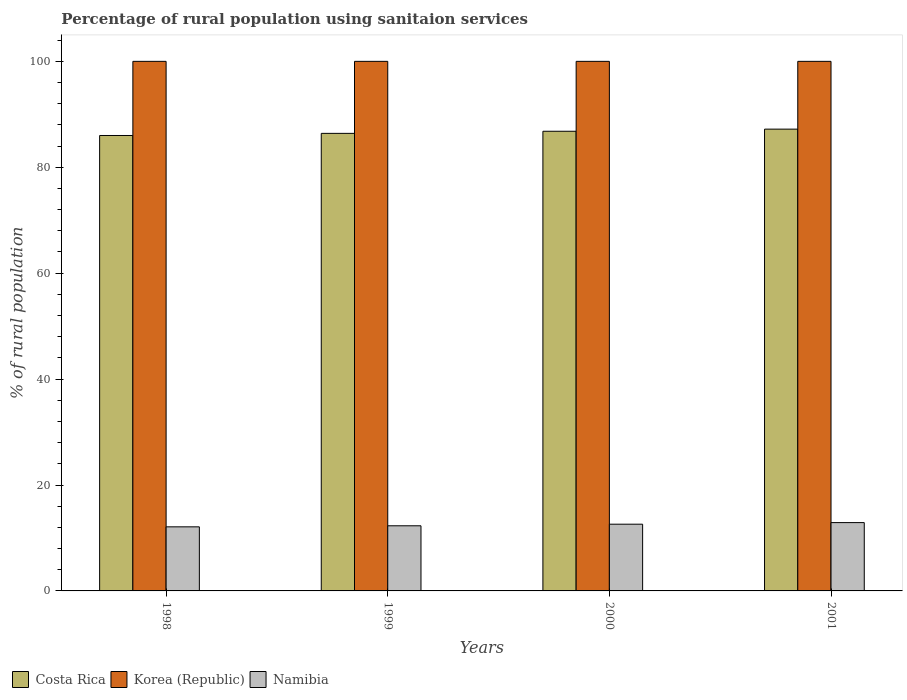How many different coloured bars are there?
Your answer should be compact. 3. How many groups of bars are there?
Your answer should be compact. 4. Are the number of bars on each tick of the X-axis equal?
Your response must be concise. Yes. How many bars are there on the 4th tick from the right?
Ensure brevity in your answer.  3. What is the label of the 3rd group of bars from the left?
Your answer should be compact. 2000. In how many cases, is the number of bars for a given year not equal to the number of legend labels?
Keep it short and to the point. 0. Across all years, what is the maximum percentage of rural population using sanitaion services in Costa Rica?
Your answer should be very brief. 87.2. In which year was the percentage of rural population using sanitaion services in Namibia minimum?
Keep it short and to the point. 1998. What is the total percentage of rural population using sanitaion services in Namibia in the graph?
Your answer should be very brief. 49.9. What is the difference between the percentage of rural population using sanitaion services in Costa Rica in 2000 and that in 2001?
Give a very brief answer. -0.4. What is the difference between the percentage of rural population using sanitaion services in Korea (Republic) in 2000 and the percentage of rural population using sanitaion services in Costa Rica in 1999?
Make the answer very short. 13.6. In the year 1998, what is the difference between the percentage of rural population using sanitaion services in Korea (Republic) and percentage of rural population using sanitaion services in Costa Rica?
Your answer should be very brief. 14. Is the percentage of rural population using sanitaion services in Korea (Republic) in 1998 less than that in 2001?
Your answer should be compact. No. Is the difference between the percentage of rural population using sanitaion services in Korea (Republic) in 1998 and 1999 greater than the difference between the percentage of rural population using sanitaion services in Costa Rica in 1998 and 1999?
Offer a very short reply. Yes. What is the difference between the highest and the second highest percentage of rural population using sanitaion services in Costa Rica?
Give a very brief answer. 0.4. What is the difference between the highest and the lowest percentage of rural population using sanitaion services in Namibia?
Your answer should be compact. 0.8. In how many years, is the percentage of rural population using sanitaion services in Costa Rica greater than the average percentage of rural population using sanitaion services in Costa Rica taken over all years?
Offer a terse response. 2. What does the 3rd bar from the left in 1999 represents?
Keep it short and to the point. Namibia. What does the 1st bar from the right in 2000 represents?
Your response must be concise. Namibia. Are all the bars in the graph horizontal?
Offer a terse response. No. What is the difference between two consecutive major ticks on the Y-axis?
Keep it short and to the point. 20. Are the values on the major ticks of Y-axis written in scientific E-notation?
Give a very brief answer. No. How many legend labels are there?
Ensure brevity in your answer.  3. How are the legend labels stacked?
Provide a short and direct response. Horizontal. What is the title of the graph?
Offer a terse response. Percentage of rural population using sanitaion services. What is the label or title of the X-axis?
Keep it short and to the point. Years. What is the label or title of the Y-axis?
Give a very brief answer. % of rural population. What is the % of rural population in Costa Rica in 1998?
Ensure brevity in your answer.  86. What is the % of rural population in Costa Rica in 1999?
Provide a succinct answer. 86.4. What is the % of rural population of Costa Rica in 2000?
Offer a terse response. 86.8. What is the % of rural population of Korea (Republic) in 2000?
Your answer should be compact. 100. What is the % of rural population in Namibia in 2000?
Make the answer very short. 12.6. What is the % of rural population in Costa Rica in 2001?
Provide a succinct answer. 87.2. Across all years, what is the maximum % of rural population of Costa Rica?
Offer a terse response. 87.2. Across all years, what is the maximum % of rural population in Korea (Republic)?
Your answer should be very brief. 100. Across all years, what is the minimum % of rural population in Costa Rica?
Offer a terse response. 86. What is the total % of rural population in Costa Rica in the graph?
Your answer should be very brief. 346.4. What is the total % of rural population of Namibia in the graph?
Your response must be concise. 49.9. What is the difference between the % of rural population in Costa Rica in 1998 and that in 1999?
Your response must be concise. -0.4. What is the difference between the % of rural population of Korea (Republic) in 1998 and that in 2000?
Your response must be concise. 0. What is the difference between the % of rural population of Costa Rica in 1998 and that in 2001?
Give a very brief answer. -1.2. What is the difference between the % of rural population of Korea (Republic) in 1998 and that in 2001?
Keep it short and to the point. 0. What is the difference between the % of rural population in Korea (Republic) in 1999 and that in 2000?
Keep it short and to the point. 0. What is the difference between the % of rural population in Namibia in 1999 and that in 2000?
Offer a terse response. -0.3. What is the difference between the % of rural population in Costa Rica in 2000 and that in 2001?
Provide a succinct answer. -0.4. What is the difference between the % of rural population of Costa Rica in 1998 and the % of rural population of Namibia in 1999?
Keep it short and to the point. 73.7. What is the difference between the % of rural population in Korea (Republic) in 1998 and the % of rural population in Namibia in 1999?
Offer a very short reply. 87.7. What is the difference between the % of rural population of Costa Rica in 1998 and the % of rural population of Korea (Republic) in 2000?
Your answer should be compact. -14. What is the difference between the % of rural population in Costa Rica in 1998 and the % of rural population in Namibia in 2000?
Your answer should be compact. 73.4. What is the difference between the % of rural population in Korea (Republic) in 1998 and the % of rural population in Namibia in 2000?
Your answer should be compact. 87.4. What is the difference between the % of rural population in Costa Rica in 1998 and the % of rural population in Namibia in 2001?
Keep it short and to the point. 73.1. What is the difference between the % of rural population in Korea (Republic) in 1998 and the % of rural population in Namibia in 2001?
Your answer should be compact. 87.1. What is the difference between the % of rural population of Costa Rica in 1999 and the % of rural population of Korea (Republic) in 2000?
Offer a very short reply. -13.6. What is the difference between the % of rural population in Costa Rica in 1999 and the % of rural population in Namibia in 2000?
Offer a very short reply. 73.8. What is the difference between the % of rural population in Korea (Republic) in 1999 and the % of rural population in Namibia in 2000?
Make the answer very short. 87.4. What is the difference between the % of rural population in Costa Rica in 1999 and the % of rural population in Namibia in 2001?
Provide a short and direct response. 73.5. What is the difference between the % of rural population in Korea (Republic) in 1999 and the % of rural population in Namibia in 2001?
Provide a succinct answer. 87.1. What is the difference between the % of rural population in Costa Rica in 2000 and the % of rural population in Korea (Republic) in 2001?
Your response must be concise. -13.2. What is the difference between the % of rural population of Costa Rica in 2000 and the % of rural population of Namibia in 2001?
Offer a very short reply. 73.9. What is the difference between the % of rural population in Korea (Republic) in 2000 and the % of rural population in Namibia in 2001?
Give a very brief answer. 87.1. What is the average % of rural population of Costa Rica per year?
Your answer should be compact. 86.6. What is the average % of rural population in Namibia per year?
Your answer should be very brief. 12.47. In the year 1998, what is the difference between the % of rural population in Costa Rica and % of rural population in Korea (Republic)?
Keep it short and to the point. -14. In the year 1998, what is the difference between the % of rural population in Costa Rica and % of rural population in Namibia?
Give a very brief answer. 73.9. In the year 1998, what is the difference between the % of rural population in Korea (Republic) and % of rural population in Namibia?
Provide a succinct answer. 87.9. In the year 1999, what is the difference between the % of rural population of Costa Rica and % of rural population of Korea (Republic)?
Keep it short and to the point. -13.6. In the year 1999, what is the difference between the % of rural population of Costa Rica and % of rural population of Namibia?
Your answer should be very brief. 74.1. In the year 1999, what is the difference between the % of rural population in Korea (Republic) and % of rural population in Namibia?
Offer a terse response. 87.7. In the year 2000, what is the difference between the % of rural population in Costa Rica and % of rural population in Korea (Republic)?
Give a very brief answer. -13.2. In the year 2000, what is the difference between the % of rural population of Costa Rica and % of rural population of Namibia?
Give a very brief answer. 74.2. In the year 2000, what is the difference between the % of rural population in Korea (Republic) and % of rural population in Namibia?
Offer a terse response. 87.4. In the year 2001, what is the difference between the % of rural population of Costa Rica and % of rural population of Korea (Republic)?
Your answer should be compact. -12.8. In the year 2001, what is the difference between the % of rural population in Costa Rica and % of rural population in Namibia?
Your response must be concise. 74.3. In the year 2001, what is the difference between the % of rural population of Korea (Republic) and % of rural population of Namibia?
Make the answer very short. 87.1. What is the ratio of the % of rural population in Costa Rica in 1998 to that in 1999?
Provide a short and direct response. 1. What is the ratio of the % of rural population in Namibia in 1998 to that in 1999?
Provide a succinct answer. 0.98. What is the ratio of the % of rural population of Korea (Republic) in 1998 to that in 2000?
Offer a terse response. 1. What is the ratio of the % of rural population of Namibia in 1998 to that in 2000?
Your response must be concise. 0.96. What is the ratio of the % of rural population of Costa Rica in 1998 to that in 2001?
Keep it short and to the point. 0.99. What is the ratio of the % of rural population in Namibia in 1998 to that in 2001?
Give a very brief answer. 0.94. What is the ratio of the % of rural population in Namibia in 1999 to that in 2000?
Your answer should be very brief. 0.98. What is the ratio of the % of rural population of Namibia in 1999 to that in 2001?
Give a very brief answer. 0.95. What is the ratio of the % of rural population of Korea (Republic) in 2000 to that in 2001?
Your answer should be compact. 1. What is the ratio of the % of rural population in Namibia in 2000 to that in 2001?
Your response must be concise. 0.98. What is the difference between the highest and the second highest % of rural population of Korea (Republic)?
Offer a very short reply. 0. What is the difference between the highest and the lowest % of rural population in Costa Rica?
Offer a very short reply. 1.2. 